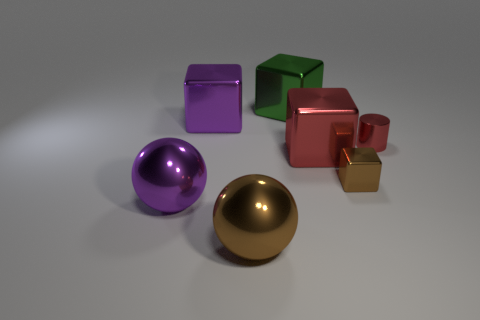Subtract 1 cubes. How many cubes are left? 3 Add 3 small purple metallic balls. How many objects exist? 10 Subtract all cylinders. How many objects are left? 6 Add 7 purple metal objects. How many purple metal objects exist? 9 Subtract 1 purple balls. How many objects are left? 6 Subtract all small blocks. Subtract all small purple metal spheres. How many objects are left? 6 Add 1 tiny brown things. How many tiny brown things are left? 2 